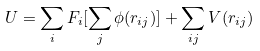Convert formula to latex. <formula><loc_0><loc_0><loc_500><loc_500>U = \sum _ { i } F _ { i } [ \sum _ { j } \phi ( r _ { i j } ) ] + \sum _ { i j } V ( r _ { i j } )</formula> 